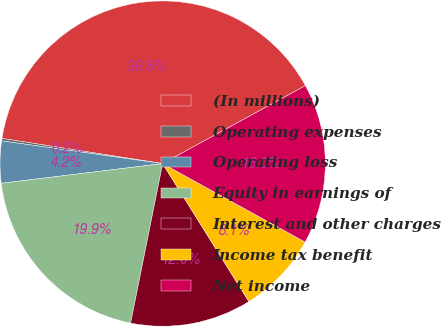Convert chart. <chart><loc_0><loc_0><loc_500><loc_500><pie_chart><fcel>(In millions)<fcel>Operating expenses<fcel>Operating loss<fcel>Equity in earnings of<fcel>Interest and other charges<fcel>Income tax benefit<fcel>Net income<nl><fcel>39.57%<fcel>0.24%<fcel>4.17%<fcel>19.91%<fcel>12.04%<fcel>8.1%<fcel>15.97%<nl></chart> 